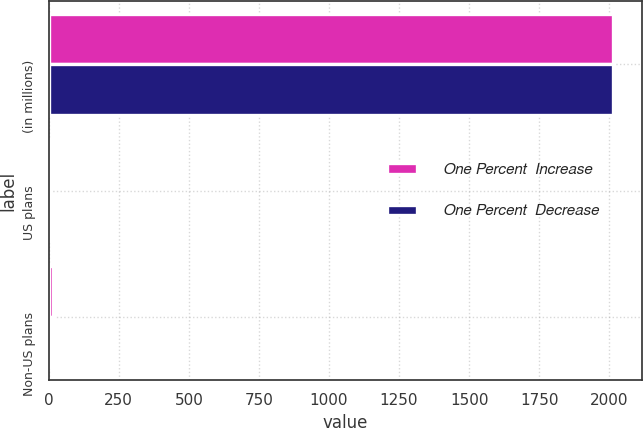Convert chart to OTSL. <chart><loc_0><loc_0><loc_500><loc_500><stacked_bar_chart><ecel><fcel>(in millions)<fcel>US plans<fcel>Non-US plans<nl><fcel>One Percent  Increase<fcel>2015<fcel>6<fcel>17<nl><fcel>One Percent  Decrease<fcel>2015<fcel>4<fcel>12<nl></chart> 